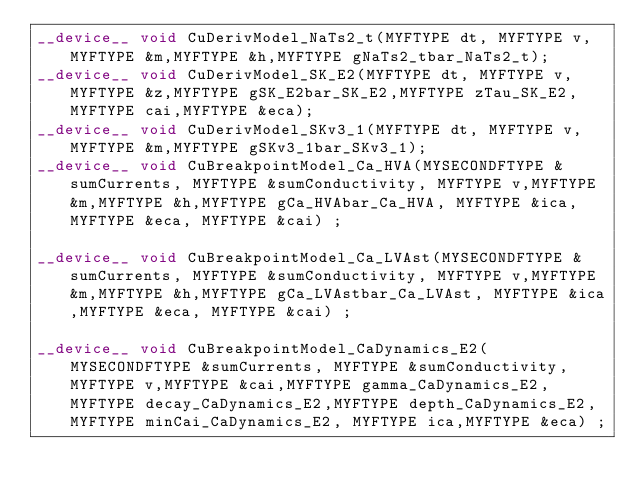Convert code to text. <code><loc_0><loc_0><loc_500><loc_500><_Cuda_>__device__ void CuDerivModel_NaTs2_t(MYFTYPE dt, MYFTYPE v,MYFTYPE &m,MYFTYPE &h,MYFTYPE gNaTs2_tbar_NaTs2_t);
__device__ void CuDerivModel_SK_E2(MYFTYPE dt, MYFTYPE v,MYFTYPE &z,MYFTYPE gSK_E2bar_SK_E2,MYFTYPE zTau_SK_E2, MYFTYPE cai,MYFTYPE &eca);
__device__ void CuDerivModel_SKv3_1(MYFTYPE dt, MYFTYPE v,MYFTYPE &m,MYFTYPE gSKv3_1bar_SKv3_1);
__device__ void CuBreakpointModel_Ca_HVA(MYSECONDFTYPE &sumCurrents, MYFTYPE &sumConductivity, MYFTYPE v,MYFTYPE &m,MYFTYPE &h,MYFTYPE gCa_HVAbar_Ca_HVA, MYFTYPE &ica,MYFTYPE &eca, MYFTYPE &cai) ;

__device__ void CuBreakpointModel_Ca_LVAst(MYSECONDFTYPE &sumCurrents, MYFTYPE &sumConductivity, MYFTYPE v,MYFTYPE &m,MYFTYPE &h,MYFTYPE gCa_LVAstbar_Ca_LVAst, MYFTYPE &ica,MYFTYPE &eca, MYFTYPE &cai) ;

__device__ void CuBreakpointModel_CaDynamics_E2(MYSECONDFTYPE &sumCurrents, MYFTYPE &sumConductivity, MYFTYPE v,MYFTYPE &cai,MYFTYPE gamma_CaDynamics_E2,MYFTYPE decay_CaDynamics_E2,MYFTYPE depth_CaDynamics_E2,MYFTYPE minCai_CaDynamics_E2, MYFTYPE ica,MYFTYPE &eca) ;
</code> 